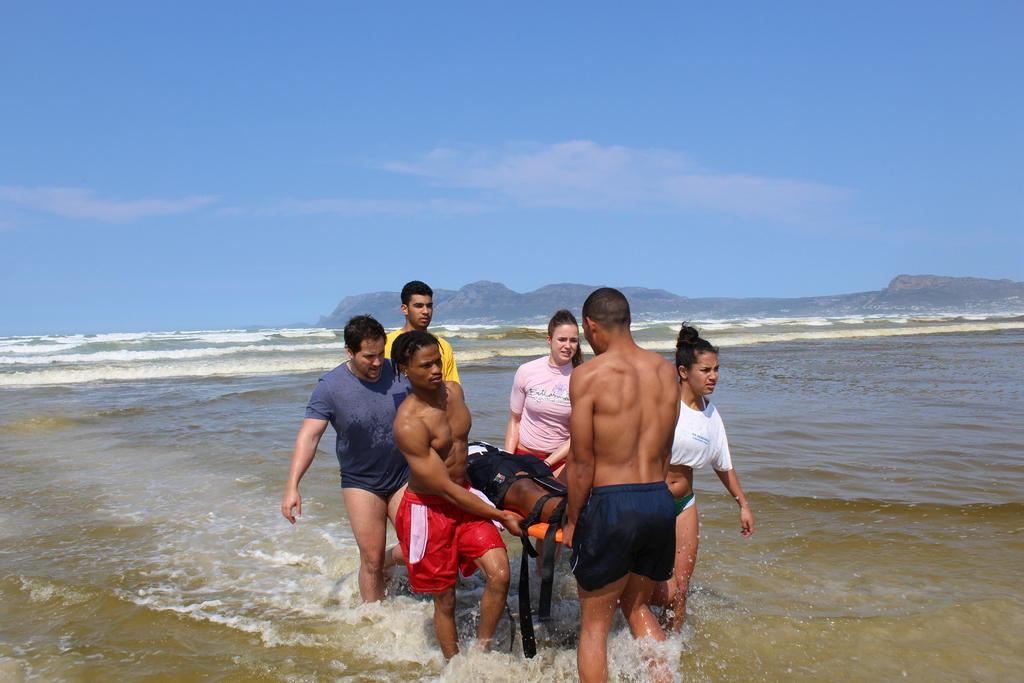What are the people in the image doing? The people are holding a person on a stretcher. Where are the people walking? The people are walking in the water. What can be seen in the background of the image? There is a hill and the sky visible in the background of the image. What type of branch can be seen in the scene? There is no branch present in the image; it features people holding a person on a stretcher while walking in the water. 